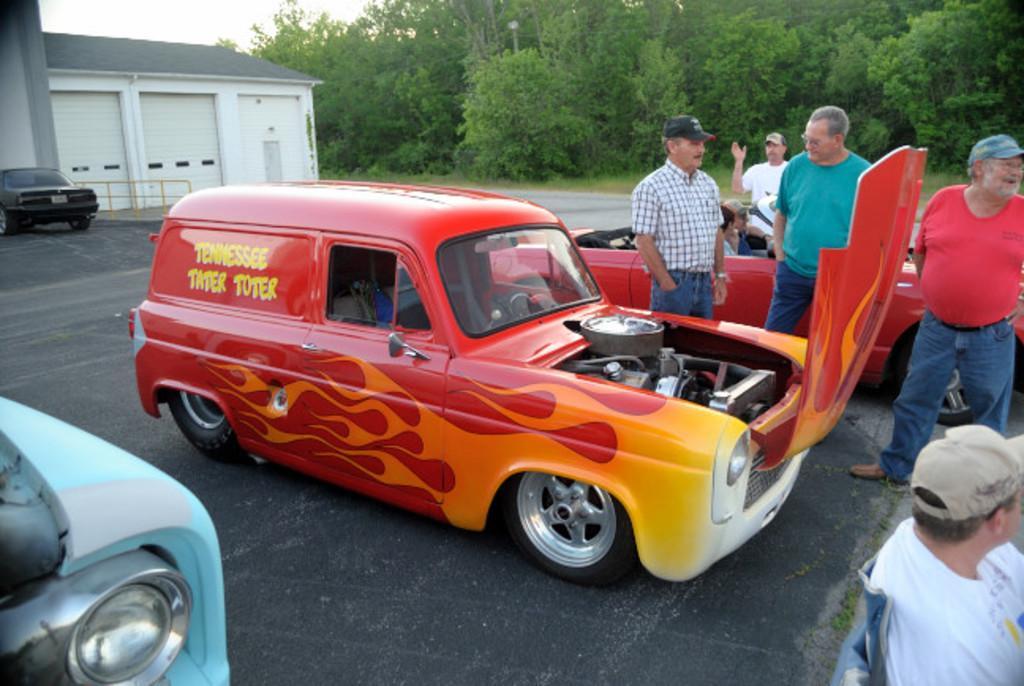Can you describe this image briefly? In this image I can see few vehicles, a building, number of trees and here I can see few people. I can also see most of them are wearing caps and here on this vehicle I can see something is written. 